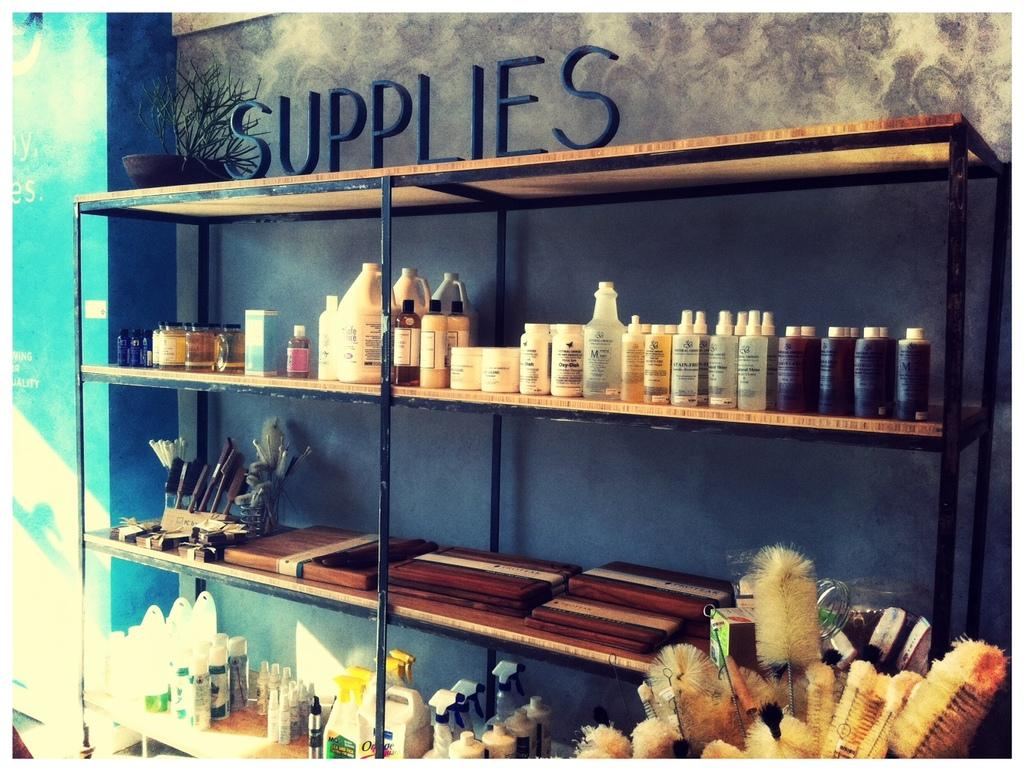<image>
Write a terse but informative summary of the picture. A supplies shelf with many different bottle on it. 